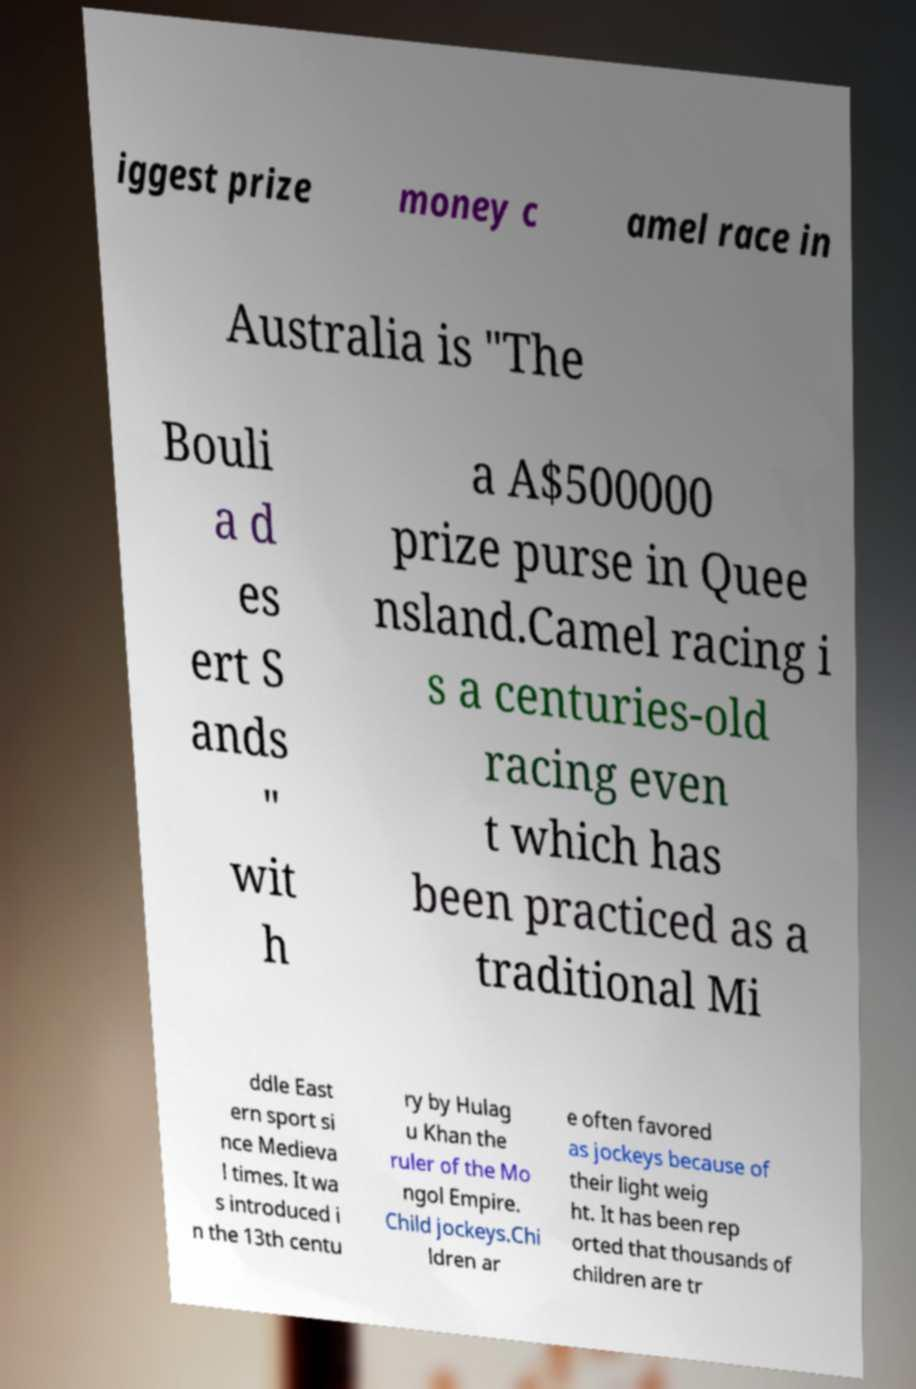Please identify and transcribe the text found in this image. iggest prize money c amel race in Australia is "The Bouli a d es ert S ands " wit h a A$500000 prize purse in Quee nsland.Camel racing i s a centuries-old racing even t which has been practiced as a traditional Mi ddle East ern sport si nce Medieva l times. It wa s introduced i n the 13th centu ry by Hulag u Khan the ruler of the Mo ngol Empire. Child jockeys.Chi ldren ar e often favored as jockeys because of their light weig ht. It has been rep orted that thousands of children are tr 